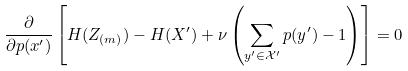<formula> <loc_0><loc_0><loc_500><loc_500>\frac { \partial } { \partial p ( x ^ { \prime } ) } \left [ H ( Z _ { ( m ) } ) - H ( X ^ { \prime } ) + \nu \left ( \sum _ { y ^ { \prime } \in \mathcal { X ^ { \prime } } } p ( y ^ { \prime } ) - 1 \right ) \right ] = 0</formula> 